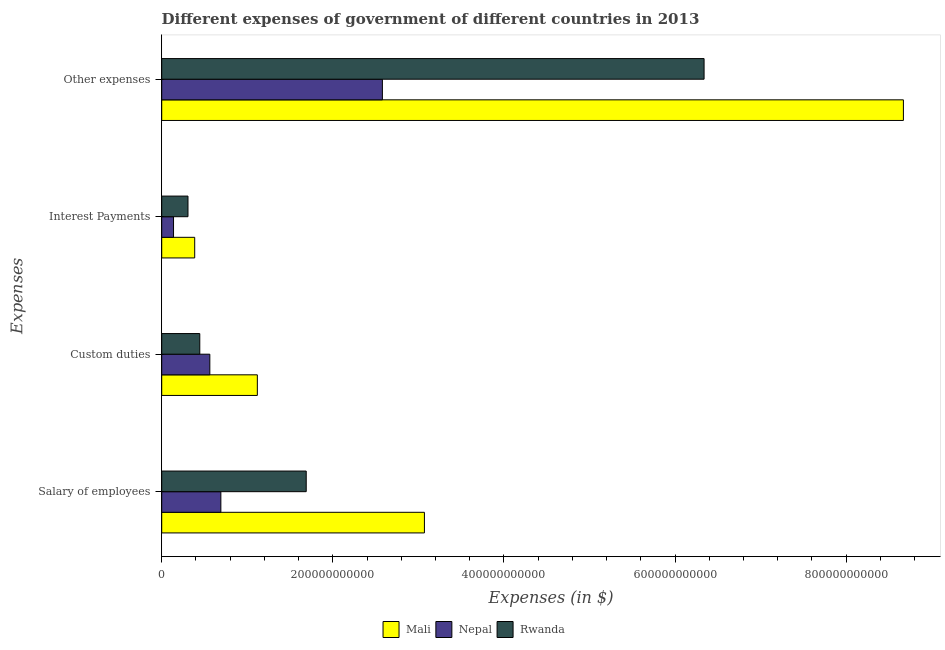How many different coloured bars are there?
Your response must be concise. 3. How many bars are there on the 4th tick from the bottom?
Offer a terse response. 3. What is the label of the 3rd group of bars from the top?
Give a very brief answer. Custom duties. What is the amount spent on interest payments in Rwanda?
Your response must be concise. 3.07e+1. Across all countries, what is the maximum amount spent on interest payments?
Your answer should be compact. 3.86e+1. Across all countries, what is the minimum amount spent on other expenses?
Make the answer very short. 2.58e+11. In which country was the amount spent on other expenses maximum?
Give a very brief answer. Mali. In which country was the amount spent on interest payments minimum?
Provide a succinct answer. Nepal. What is the total amount spent on salary of employees in the graph?
Your answer should be very brief. 5.45e+11. What is the difference between the amount spent on custom duties in Nepal and that in Rwanda?
Offer a terse response. 1.17e+1. What is the difference between the amount spent on interest payments in Nepal and the amount spent on salary of employees in Mali?
Ensure brevity in your answer.  -2.93e+11. What is the average amount spent on other expenses per country?
Offer a very short reply. 5.86e+11. What is the difference between the amount spent on salary of employees and amount spent on other expenses in Nepal?
Ensure brevity in your answer.  -1.89e+11. In how many countries, is the amount spent on salary of employees greater than 80000000000 $?
Provide a short and direct response. 2. What is the ratio of the amount spent on custom duties in Mali to that in Rwanda?
Provide a succinct answer. 2.51. Is the difference between the amount spent on interest payments in Rwanda and Nepal greater than the difference between the amount spent on other expenses in Rwanda and Nepal?
Give a very brief answer. No. What is the difference between the highest and the second highest amount spent on salary of employees?
Your answer should be very brief. 1.38e+11. What is the difference between the highest and the lowest amount spent on other expenses?
Ensure brevity in your answer.  6.09e+11. In how many countries, is the amount spent on custom duties greater than the average amount spent on custom duties taken over all countries?
Give a very brief answer. 1. Is it the case that in every country, the sum of the amount spent on interest payments and amount spent on custom duties is greater than the sum of amount spent on other expenses and amount spent on salary of employees?
Offer a terse response. No. What does the 3rd bar from the top in Custom duties represents?
Make the answer very short. Mali. What does the 3rd bar from the bottom in Custom duties represents?
Give a very brief answer. Rwanda. Is it the case that in every country, the sum of the amount spent on salary of employees and amount spent on custom duties is greater than the amount spent on interest payments?
Offer a terse response. Yes. Are all the bars in the graph horizontal?
Give a very brief answer. Yes. How many countries are there in the graph?
Keep it short and to the point. 3. What is the difference between two consecutive major ticks on the X-axis?
Provide a succinct answer. 2.00e+11. Are the values on the major ticks of X-axis written in scientific E-notation?
Your response must be concise. No. Does the graph contain any zero values?
Ensure brevity in your answer.  No. Does the graph contain grids?
Your answer should be compact. No. Where does the legend appear in the graph?
Ensure brevity in your answer.  Bottom center. How many legend labels are there?
Ensure brevity in your answer.  3. How are the legend labels stacked?
Give a very brief answer. Horizontal. What is the title of the graph?
Provide a short and direct response. Different expenses of government of different countries in 2013. What is the label or title of the X-axis?
Make the answer very short. Expenses (in $). What is the label or title of the Y-axis?
Offer a very short reply. Expenses. What is the Expenses (in $) in Mali in Salary of employees?
Your answer should be very brief. 3.07e+11. What is the Expenses (in $) of Nepal in Salary of employees?
Your answer should be very brief. 6.91e+1. What is the Expenses (in $) in Rwanda in Salary of employees?
Your response must be concise. 1.69e+11. What is the Expenses (in $) of Mali in Custom duties?
Give a very brief answer. 1.12e+11. What is the Expenses (in $) of Nepal in Custom duties?
Make the answer very short. 5.62e+1. What is the Expenses (in $) in Rwanda in Custom duties?
Make the answer very short. 4.45e+1. What is the Expenses (in $) of Mali in Interest Payments?
Keep it short and to the point. 3.86e+1. What is the Expenses (in $) in Nepal in Interest Payments?
Ensure brevity in your answer.  1.38e+1. What is the Expenses (in $) in Rwanda in Interest Payments?
Keep it short and to the point. 3.07e+1. What is the Expenses (in $) in Mali in Other expenses?
Give a very brief answer. 8.67e+11. What is the Expenses (in $) in Nepal in Other expenses?
Your answer should be very brief. 2.58e+11. What is the Expenses (in $) of Rwanda in Other expenses?
Offer a terse response. 6.34e+11. Across all Expenses, what is the maximum Expenses (in $) of Mali?
Provide a succinct answer. 8.67e+11. Across all Expenses, what is the maximum Expenses (in $) of Nepal?
Provide a short and direct response. 2.58e+11. Across all Expenses, what is the maximum Expenses (in $) of Rwanda?
Your answer should be compact. 6.34e+11. Across all Expenses, what is the minimum Expenses (in $) in Mali?
Keep it short and to the point. 3.86e+1. Across all Expenses, what is the minimum Expenses (in $) in Nepal?
Your answer should be very brief. 1.38e+1. Across all Expenses, what is the minimum Expenses (in $) of Rwanda?
Keep it short and to the point. 3.07e+1. What is the total Expenses (in $) of Mali in the graph?
Provide a succinct answer. 1.32e+12. What is the total Expenses (in $) of Nepal in the graph?
Offer a very short reply. 3.97e+11. What is the total Expenses (in $) of Rwanda in the graph?
Your response must be concise. 8.78e+11. What is the difference between the Expenses (in $) in Mali in Salary of employees and that in Custom duties?
Make the answer very short. 1.95e+11. What is the difference between the Expenses (in $) in Nepal in Salary of employees and that in Custom duties?
Give a very brief answer. 1.29e+1. What is the difference between the Expenses (in $) of Rwanda in Salary of employees and that in Custom duties?
Offer a very short reply. 1.24e+11. What is the difference between the Expenses (in $) of Mali in Salary of employees and that in Interest Payments?
Provide a short and direct response. 2.68e+11. What is the difference between the Expenses (in $) in Nepal in Salary of employees and that in Interest Payments?
Make the answer very short. 5.53e+1. What is the difference between the Expenses (in $) in Rwanda in Salary of employees and that in Interest Payments?
Offer a very short reply. 1.38e+11. What is the difference between the Expenses (in $) in Mali in Salary of employees and that in Other expenses?
Keep it short and to the point. -5.60e+11. What is the difference between the Expenses (in $) of Nepal in Salary of employees and that in Other expenses?
Your response must be concise. -1.89e+11. What is the difference between the Expenses (in $) of Rwanda in Salary of employees and that in Other expenses?
Make the answer very short. -4.65e+11. What is the difference between the Expenses (in $) in Mali in Custom duties and that in Interest Payments?
Provide a short and direct response. 7.32e+1. What is the difference between the Expenses (in $) in Nepal in Custom duties and that in Interest Payments?
Your answer should be compact. 4.24e+1. What is the difference between the Expenses (in $) of Rwanda in Custom duties and that in Interest Payments?
Provide a succinct answer. 1.38e+1. What is the difference between the Expenses (in $) in Mali in Custom duties and that in Other expenses?
Ensure brevity in your answer.  -7.55e+11. What is the difference between the Expenses (in $) in Nepal in Custom duties and that in Other expenses?
Offer a terse response. -2.02e+11. What is the difference between the Expenses (in $) of Rwanda in Custom duties and that in Other expenses?
Offer a very short reply. -5.89e+11. What is the difference between the Expenses (in $) of Mali in Interest Payments and that in Other expenses?
Make the answer very short. -8.28e+11. What is the difference between the Expenses (in $) in Nepal in Interest Payments and that in Other expenses?
Make the answer very short. -2.44e+11. What is the difference between the Expenses (in $) of Rwanda in Interest Payments and that in Other expenses?
Your answer should be compact. -6.03e+11. What is the difference between the Expenses (in $) of Mali in Salary of employees and the Expenses (in $) of Nepal in Custom duties?
Offer a very short reply. 2.51e+11. What is the difference between the Expenses (in $) of Mali in Salary of employees and the Expenses (in $) of Rwanda in Custom duties?
Your answer should be compact. 2.63e+11. What is the difference between the Expenses (in $) of Nepal in Salary of employees and the Expenses (in $) of Rwanda in Custom duties?
Your answer should be compact. 2.46e+1. What is the difference between the Expenses (in $) of Mali in Salary of employees and the Expenses (in $) of Nepal in Interest Payments?
Ensure brevity in your answer.  2.93e+11. What is the difference between the Expenses (in $) in Mali in Salary of employees and the Expenses (in $) in Rwanda in Interest Payments?
Your response must be concise. 2.76e+11. What is the difference between the Expenses (in $) of Nepal in Salary of employees and the Expenses (in $) of Rwanda in Interest Payments?
Provide a succinct answer. 3.84e+1. What is the difference between the Expenses (in $) of Mali in Salary of employees and the Expenses (in $) of Nepal in Other expenses?
Make the answer very short. 4.91e+1. What is the difference between the Expenses (in $) in Mali in Salary of employees and the Expenses (in $) in Rwanda in Other expenses?
Offer a very short reply. -3.27e+11. What is the difference between the Expenses (in $) of Nepal in Salary of employees and the Expenses (in $) of Rwanda in Other expenses?
Give a very brief answer. -5.65e+11. What is the difference between the Expenses (in $) of Mali in Custom duties and the Expenses (in $) of Nepal in Interest Payments?
Provide a short and direct response. 9.80e+1. What is the difference between the Expenses (in $) of Mali in Custom duties and the Expenses (in $) of Rwanda in Interest Payments?
Give a very brief answer. 8.11e+1. What is the difference between the Expenses (in $) of Nepal in Custom duties and the Expenses (in $) of Rwanda in Interest Payments?
Provide a succinct answer. 2.55e+1. What is the difference between the Expenses (in $) in Mali in Custom duties and the Expenses (in $) in Nepal in Other expenses?
Provide a short and direct response. -1.46e+11. What is the difference between the Expenses (in $) of Mali in Custom duties and the Expenses (in $) of Rwanda in Other expenses?
Offer a terse response. -5.22e+11. What is the difference between the Expenses (in $) of Nepal in Custom duties and the Expenses (in $) of Rwanda in Other expenses?
Provide a short and direct response. -5.78e+11. What is the difference between the Expenses (in $) of Mali in Interest Payments and the Expenses (in $) of Nepal in Other expenses?
Your response must be concise. -2.19e+11. What is the difference between the Expenses (in $) of Mali in Interest Payments and the Expenses (in $) of Rwanda in Other expenses?
Make the answer very short. -5.95e+11. What is the difference between the Expenses (in $) in Nepal in Interest Payments and the Expenses (in $) in Rwanda in Other expenses?
Ensure brevity in your answer.  -6.20e+11. What is the average Expenses (in $) in Mali per Expenses?
Provide a short and direct response. 3.31e+11. What is the average Expenses (in $) in Nepal per Expenses?
Provide a succinct answer. 9.93e+1. What is the average Expenses (in $) of Rwanda per Expenses?
Give a very brief answer. 2.20e+11. What is the difference between the Expenses (in $) of Mali and Expenses (in $) of Nepal in Salary of employees?
Offer a very short reply. 2.38e+11. What is the difference between the Expenses (in $) of Mali and Expenses (in $) of Rwanda in Salary of employees?
Provide a succinct answer. 1.38e+11. What is the difference between the Expenses (in $) of Nepal and Expenses (in $) of Rwanda in Salary of employees?
Your answer should be compact. -9.98e+1. What is the difference between the Expenses (in $) of Mali and Expenses (in $) of Nepal in Custom duties?
Offer a very short reply. 5.55e+1. What is the difference between the Expenses (in $) in Mali and Expenses (in $) in Rwanda in Custom duties?
Your response must be concise. 6.73e+1. What is the difference between the Expenses (in $) in Nepal and Expenses (in $) in Rwanda in Custom duties?
Offer a very short reply. 1.17e+1. What is the difference between the Expenses (in $) in Mali and Expenses (in $) in Nepal in Interest Payments?
Your answer should be very brief. 2.47e+1. What is the difference between the Expenses (in $) of Mali and Expenses (in $) of Rwanda in Interest Payments?
Your answer should be very brief. 7.86e+09. What is the difference between the Expenses (in $) of Nepal and Expenses (in $) of Rwanda in Interest Payments?
Offer a very short reply. -1.69e+1. What is the difference between the Expenses (in $) of Mali and Expenses (in $) of Nepal in Other expenses?
Ensure brevity in your answer.  6.09e+11. What is the difference between the Expenses (in $) in Mali and Expenses (in $) in Rwanda in Other expenses?
Give a very brief answer. 2.33e+11. What is the difference between the Expenses (in $) in Nepal and Expenses (in $) in Rwanda in Other expenses?
Make the answer very short. -3.76e+11. What is the ratio of the Expenses (in $) in Mali in Salary of employees to that in Custom duties?
Provide a succinct answer. 2.75. What is the ratio of the Expenses (in $) in Nepal in Salary of employees to that in Custom duties?
Make the answer very short. 1.23. What is the ratio of the Expenses (in $) in Rwanda in Salary of employees to that in Custom duties?
Provide a short and direct response. 3.8. What is the ratio of the Expenses (in $) in Mali in Salary of employees to that in Interest Payments?
Make the answer very short. 7.96. What is the ratio of the Expenses (in $) of Nepal in Salary of employees to that in Interest Payments?
Offer a very short reply. 5.01. What is the ratio of the Expenses (in $) in Rwanda in Salary of employees to that in Interest Payments?
Make the answer very short. 5.5. What is the ratio of the Expenses (in $) in Mali in Salary of employees to that in Other expenses?
Ensure brevity in your answer.  0.35. What is the ratio of the Expenses (in $) of Nepal in Salary of employees to that in Other expenses?
Provide a succinct answer. 0.27. What is the ratio of the Expenses (in $) of Rwanda in Salary of employees to that in Other expenses?
Your answer should be compact. 0.27. What is the ratio of the Expenses (in $) in Mali in Custom duties to that in Interest Payments?
Your answer should be very brief. 2.9. What is the ratio of the Expenses (in $) of Nepal in Custom duties to that in Interest Payments?
Offer a terse response. 4.07. What is the ratio of the Expenses (in $) of Rwanda in Custom duties to that in Interest Payments?
Ensure brevity in your answer.  1.45. What is the ratio of the Expenses (in $) in Mali in Custom duties to that in Other expenses?
Provide a succinct answer. 0.13. What is the ratio of the Expenses (in $) of Nepal in Custom duties to that in Other expenses?
Offer a very short reply. 0.22. What is the ratio of the Expenses (in $) in Rwanda in Custom duties to that in Other expenses?
Offer a very short reply. 0.07. What is the ratio of the Expenses (in $) of Mali in Interest Payments to that in Other expenses?
Give a very brief answer. 0.04. What is the ratio of the Expenses (in $) of Nepal in Interest Payments to that in Other expenses?
Keep it short and to the point. 0.05. What is the ratio of the Expenses (in $) in Rwanda in Interest Payments to that in Other expenses?
Keep it short and to the point. 0.05. What is the difference between the highest and the second highest Expenses (in $) of Mali?
Provide a short and direct response. 5.60e+11. What is the difference between the highest and the second highest Expenses (in $) of Nepal?
Your answer should be very brief. 1.89e+11. What is the difference between the highest and the second highest Expenses (in $) of Rwanda?
Provide a succinct answer. 4.65e+11. What is the difference between the highest and the lowest Expenses (in $) in Mali?
Your answer should be compact. 8.28e+11. What is the difference between the highest and the lowest Expenses (in $) of Nepal?
Your answer should be very brief. 2.44e+11. What is the difference between the highest and the lowest Expenses (in $) of Rwanda?
Offer a very short reply. 6.03e+11. 